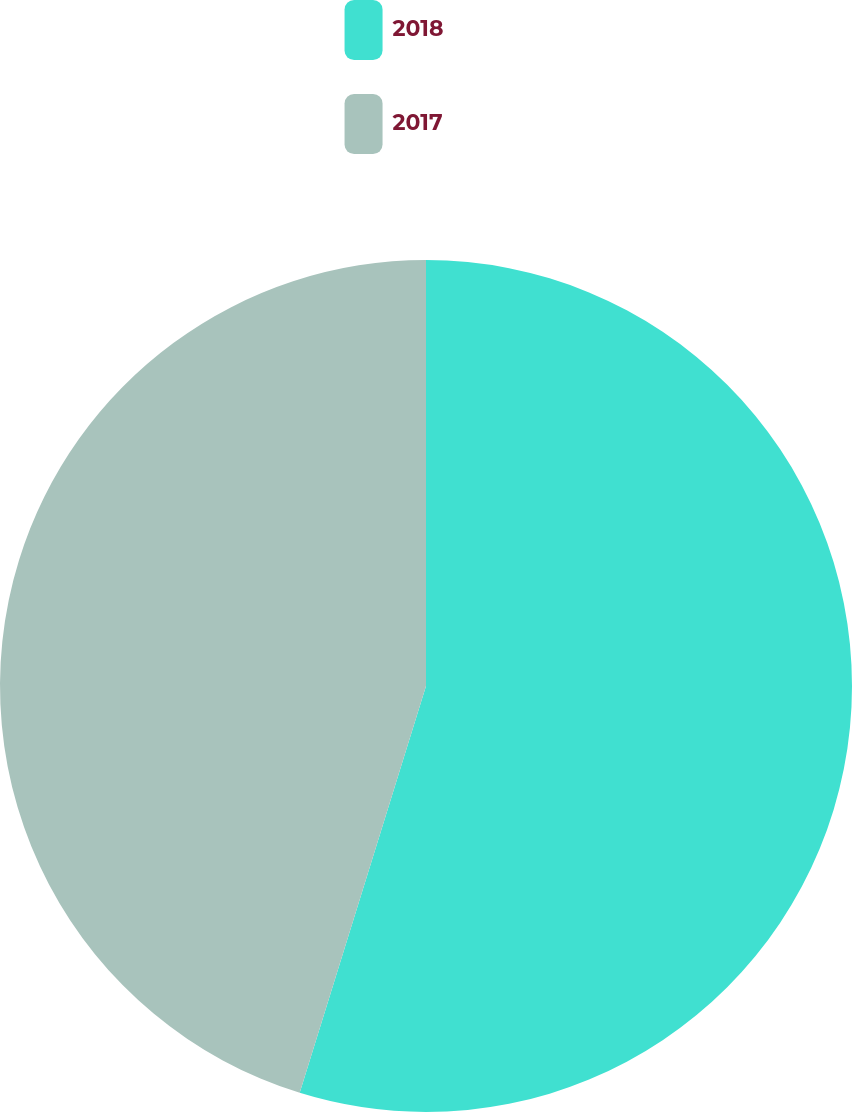Convert chart to OTSL. <chart><loc_0><loc_0><loc_500><loc_500><pie_chart><fcel>2018<fcel>2017<nl><fcel>54.79%<fcel>45.21%<nl></chart> 